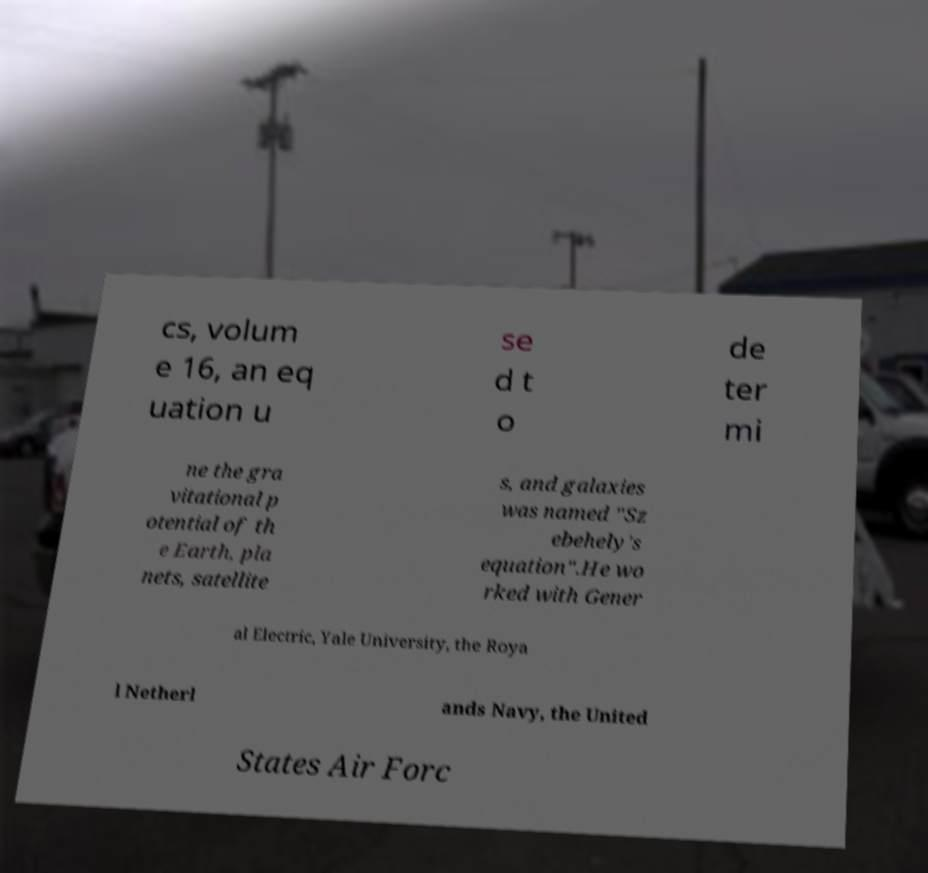Can you accurately transcribe the text from the provided image for me? cs, volum e 16, an eq uation u se d t o de ter mi ne the gra vitational p otential of th e Earth, pla nets, satellite s, and galaxies was named "Sz ebehely's equation".He wo rked with Gener al Electric, Yale University, the Roya l Netherl ands Navy, the United States Air Forc 